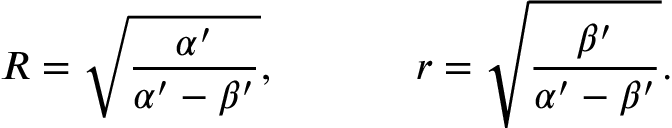<formula> <loc_0><loc_0><loc_500><loc_500>R = \sqrt { \frac { \alpha ^ { \prime } } { \alpha ^ { \prime } - \beta ^ { \prime } } } , r = \sqrt { \frac { \beta ^ { \prime } } { \alpha ^ { \prime } - \beta ^ { \prime } } } .</formula> 